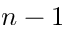<formula> <loc_0><loc_0><loc_500><loc_500>n - 1</formula> 